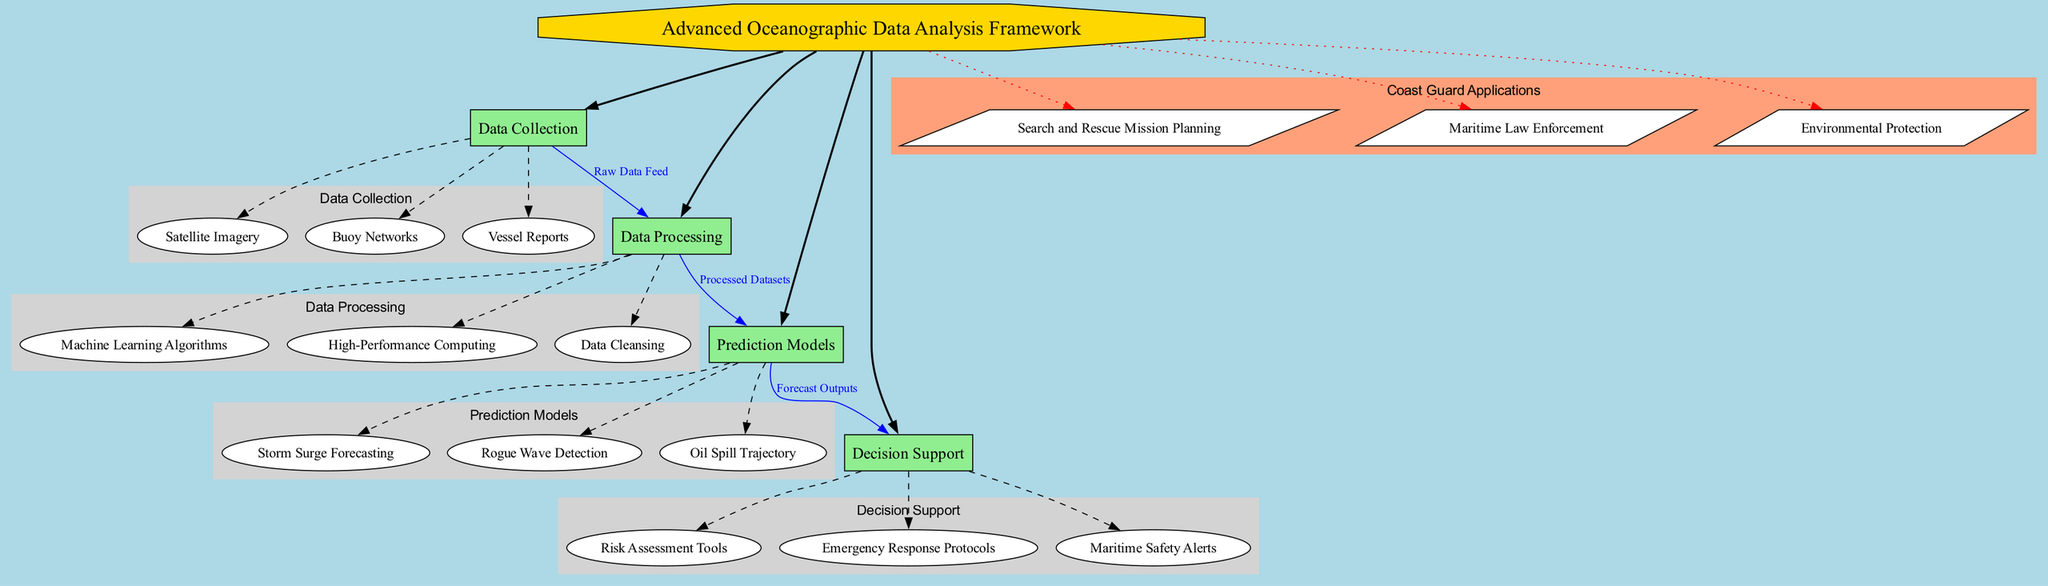What is the central topic of the diagram? The central topic is prominently displayed at the top of the diagram within an octagon shape, labeled "Advanced Oceanographic Data Analysis Framework."
Answer: Advanced Oceanographic Data Analysis Framework How many main components are there in the diagram? The diagram shows a total of four main components branching from the central topic, each identified with a box.
Answer: 4 What type of data is used in the Data Collection component? The Data Collection component includes various methods, specifically satellite imagery, buoy networks, and vessel reports, all listed as subcomponents of this category.
Answer: Satellite Imagery, Buoy Networks, Vessel Reports Which component does the Raw Data Feed relate to? The relationship labeled "Raw Data Feed" is drawn from the Data Collection component to the Data Processing component, indicating that the raw data collected feeds into the processing stage.
Answer: Data Processing What type of forecasting is included in the Prediction Models component? The Prediction Models component includes several forecasting types, one of which is "Storm Surge Forecasting" specifically listed among the subcomponents.
Answer: Storm Surge Forecasting What does the Decision Support component rely on for its outputs? The Decision Support component relies on the processed outputs coming from the Prediction Models, as indicated by the relationship labeled "Forecast Outputs."
Answer: Forecast Outputs What color represents the Coast Guard Applications cluster in the diagram? The Coast Guard Applications cluster is distinguished by the color "lightsalmon," as represented in the subgraph label and the nodes within that cluster.
Answer: Lightsalmon Which main component connects to the Emergency Response Protocols? The Emergency Response Protocols are part of the Decision Support component, which is connected as a subcomponent related to the outputs generated from the Prediction Models component.
Answer: Decision Support How many applications are listed under Coast Guard Applications? The diagram details three specific applications under the Coast Guard Applications cluster, shown in parallelogram shapes attached to the central topic with dotted edges.
Answer: 3 